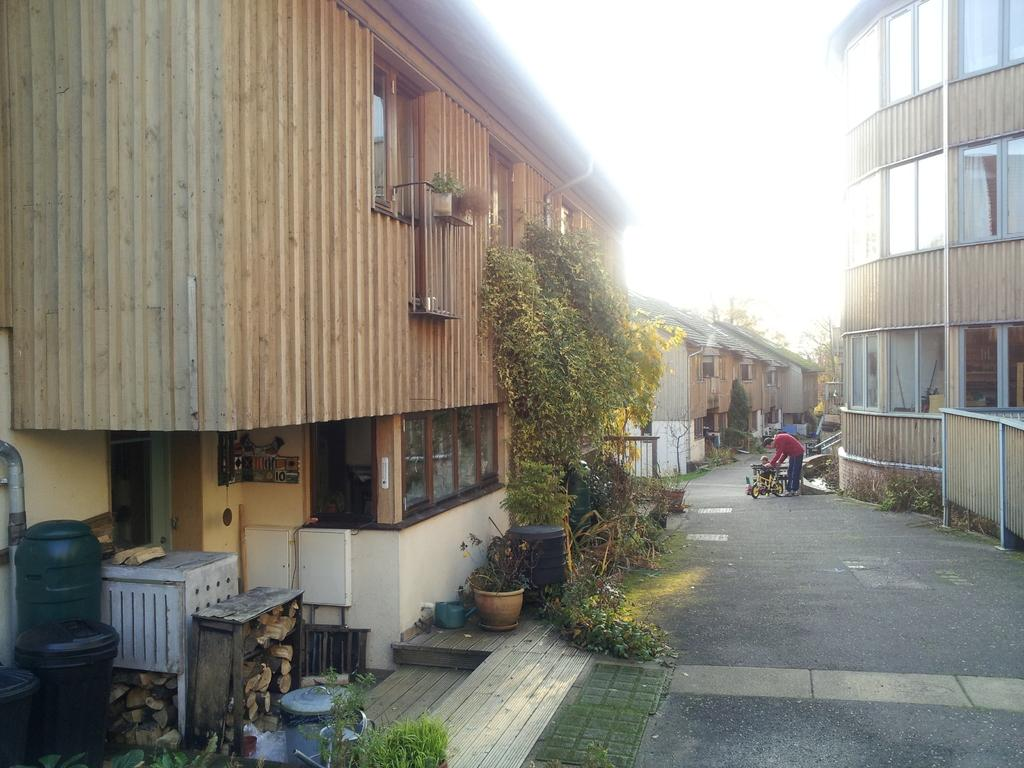What can be seen on the ground in the image? There are people on the ground in the image. What type of structures are visible in the image? There are buildings in the image. What type of vegetation is present in the image? There are trees and plants in the image, including a houseplant. What other objects can be seen in the image? There are wooden logs and some other objects in the image. What is visible in the background of the image? The sky is visible in the background of the image. What committee is meeting in the image? There is no committee meeting in the image; it features people, buildings, trees, plants, wooden logs, and objects. Can you tell me the name of the sister in the image? There is no sister present in the image. 